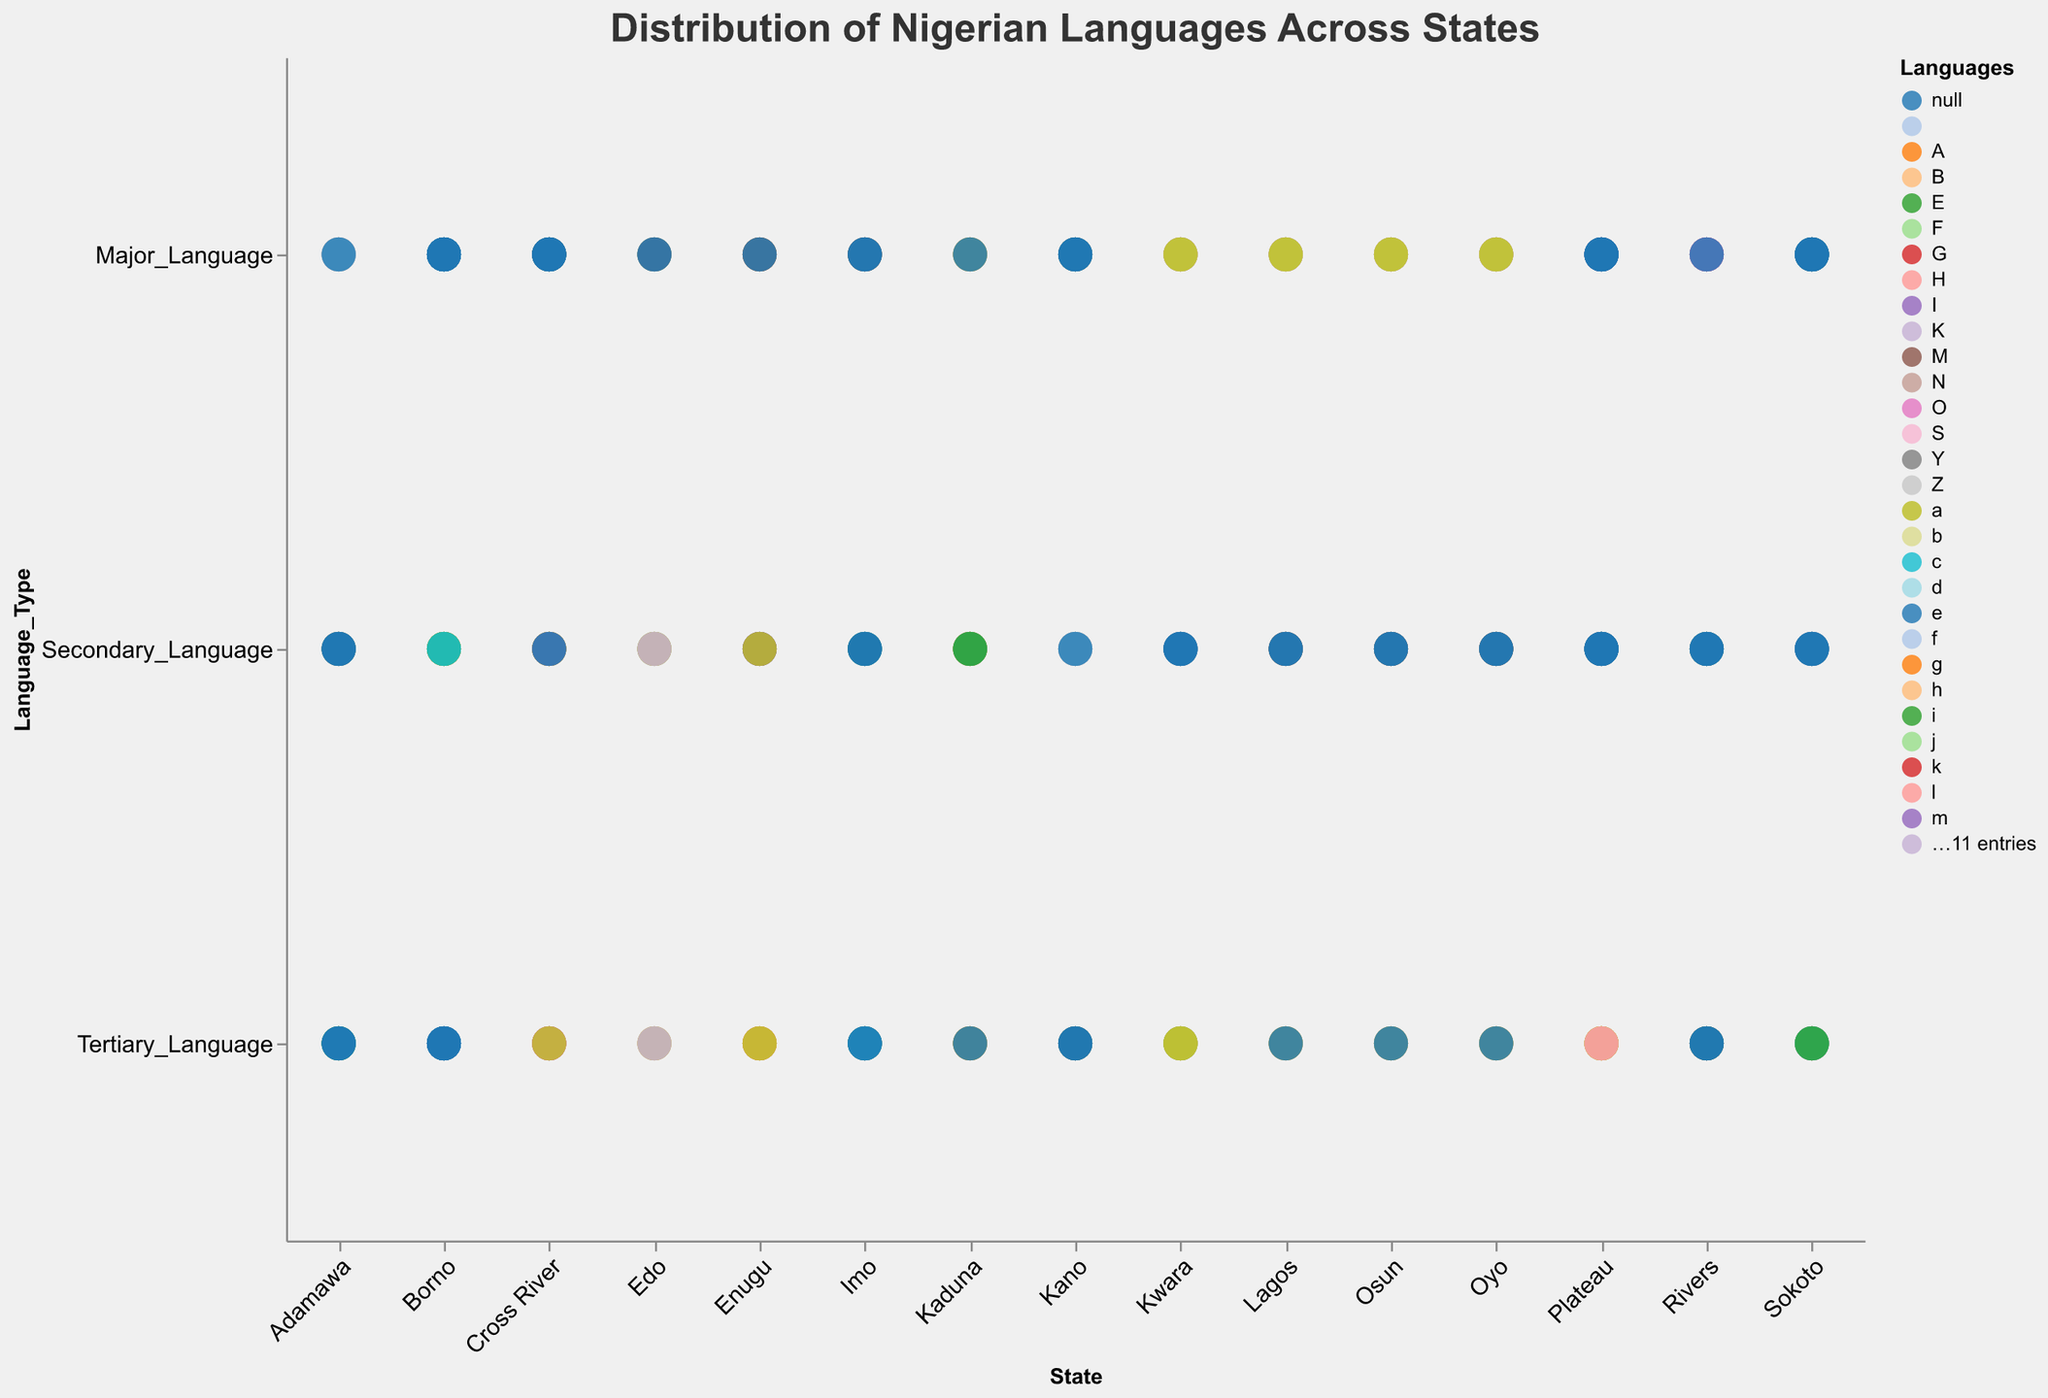What is the major language spoken in Lagos? The figure shows the distribution of Nigerian languages across different states, with Lagos labeled and the major language indicated in the corresponding section.
Answer: Yoruba Which state has Kanuri as one of its prominent languages? By looking at the plot, identify the states where Kanuri is marked. The dot for Borno highlights Kanuri.
Answer: Borno How many language types are shown for each state? Each state in the plot displays circles representing different languages. There are three circles per state, representing Major, Secondary, and Tertiary languages.
Answer: Three Which states have Hausa as their major language? Locate the circles marked as Major_Language and colored for Hausa in the plot. These states include Kano, Kaduna, and Sokoto.
Answer: Kano, Kaduna, Sokoto In Rivers, what are the secondary and tertiary languages? For Rivers, check the corresponding section for Secondary_Language and Tertiary_Language. The labels will indicate Ijaw and Ogoni.
Answer: Ijaw, Ogoni Is Yoruba spoken as a major language in more states than Hausa? Count the states where Yoruba is marked as Major_Language and compare them to the number where Hausa is marked as Major_Language. Yoruba (Lagos, Oyo, Kwara, Osun) vs. Hausa (Kano, Kaduna, Sokoto).
Answer: No Which language appears both as a major and secondary language in different states? Check for a language that shows up as a Major_Language in one state and as a Secondary_Language in another. Hausa is one of such languages.
Answer: Hausa How does the linguistic diversity of Cross River compare to that of Edo based on the languages shown? Observe the different languages represented in the plot for Cross River and Edo. Cross River has Efik, Ejagham, Bekwarra, while Edo has Edo, Esan, Owan. Both states have three languages each indicating similar diversity.
Answer: Similar What are the tertiary languages in Plateau and Enugu? Examine the sections of the plot labeled for Plateau and Enugu and identify their Tertiary_Language markers, which are Mwaghavul for Plateau and Igala for Enugu.
Answer: Mwaghavul, Igala Which states share Yoruba as a secondary language? Look for states where Yoruba is indicated as Secondary_Language in the plot. It appears in Lagos, Oyo, Osun, and Kwara as all of them have Yoruba as Major_Language and no state has it Secondary.
Answer: None 